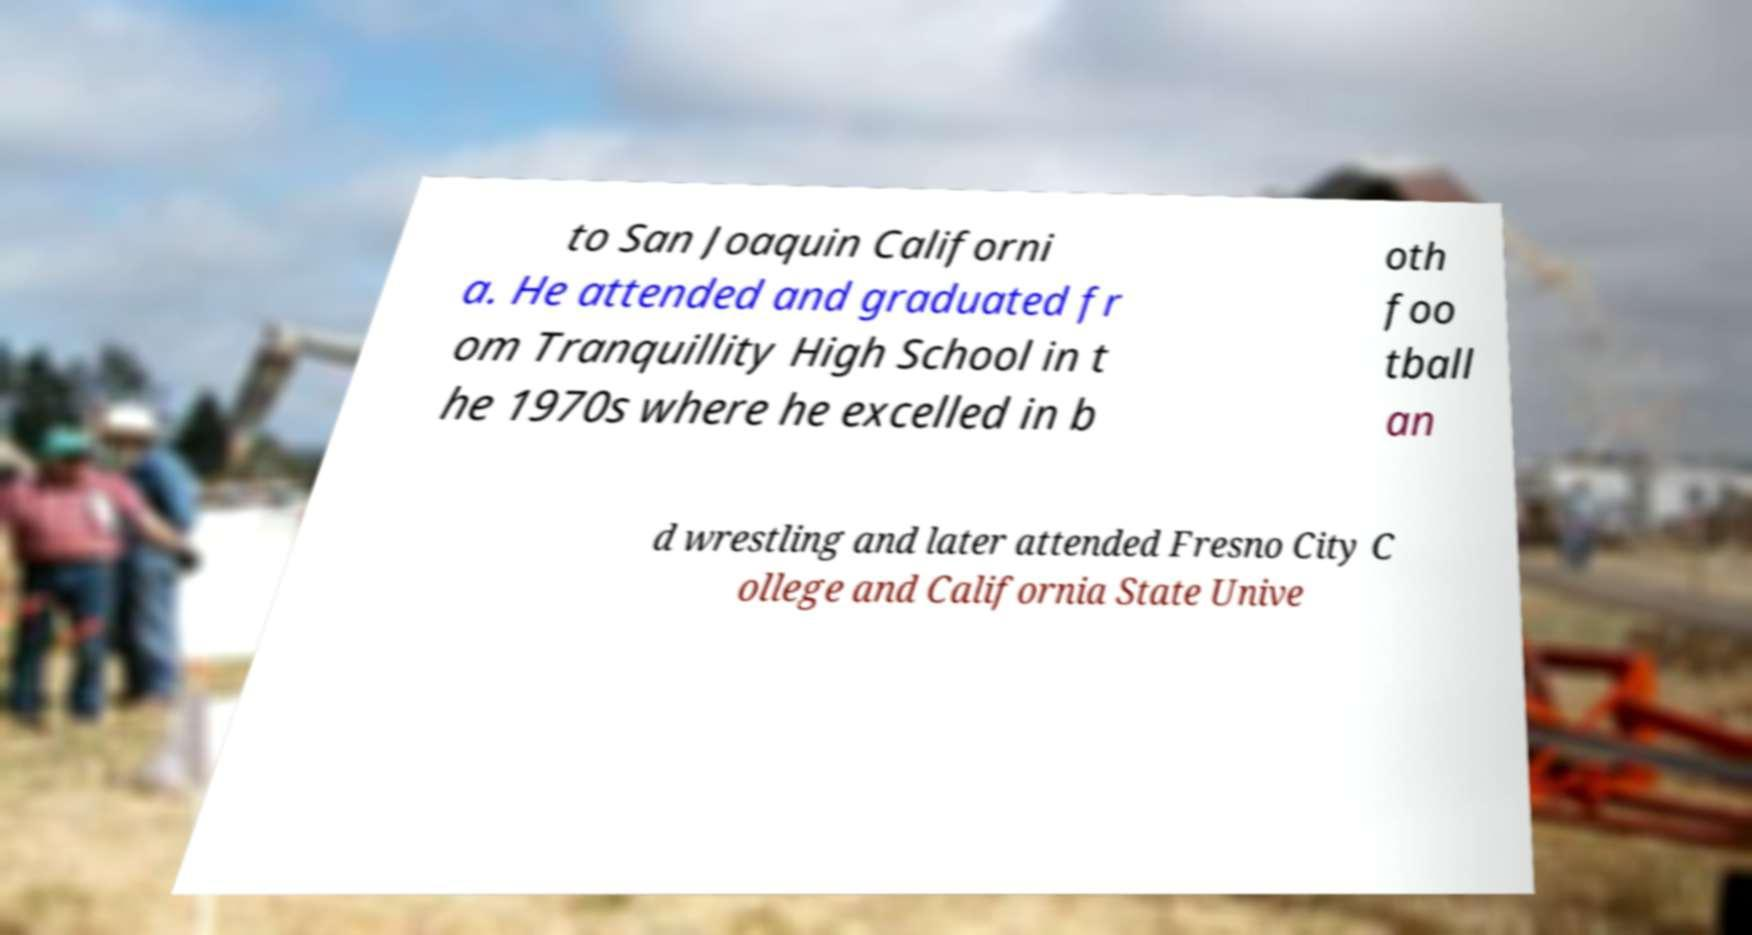Could you extract and type out the text from this image? to San Joaquin Californi a. He attended and graduated fr om Tranquillity High School in t he 1970s where he excelled in b oth foo tball an d wrestling and later attended Fresno City C ollege and California State Unive 